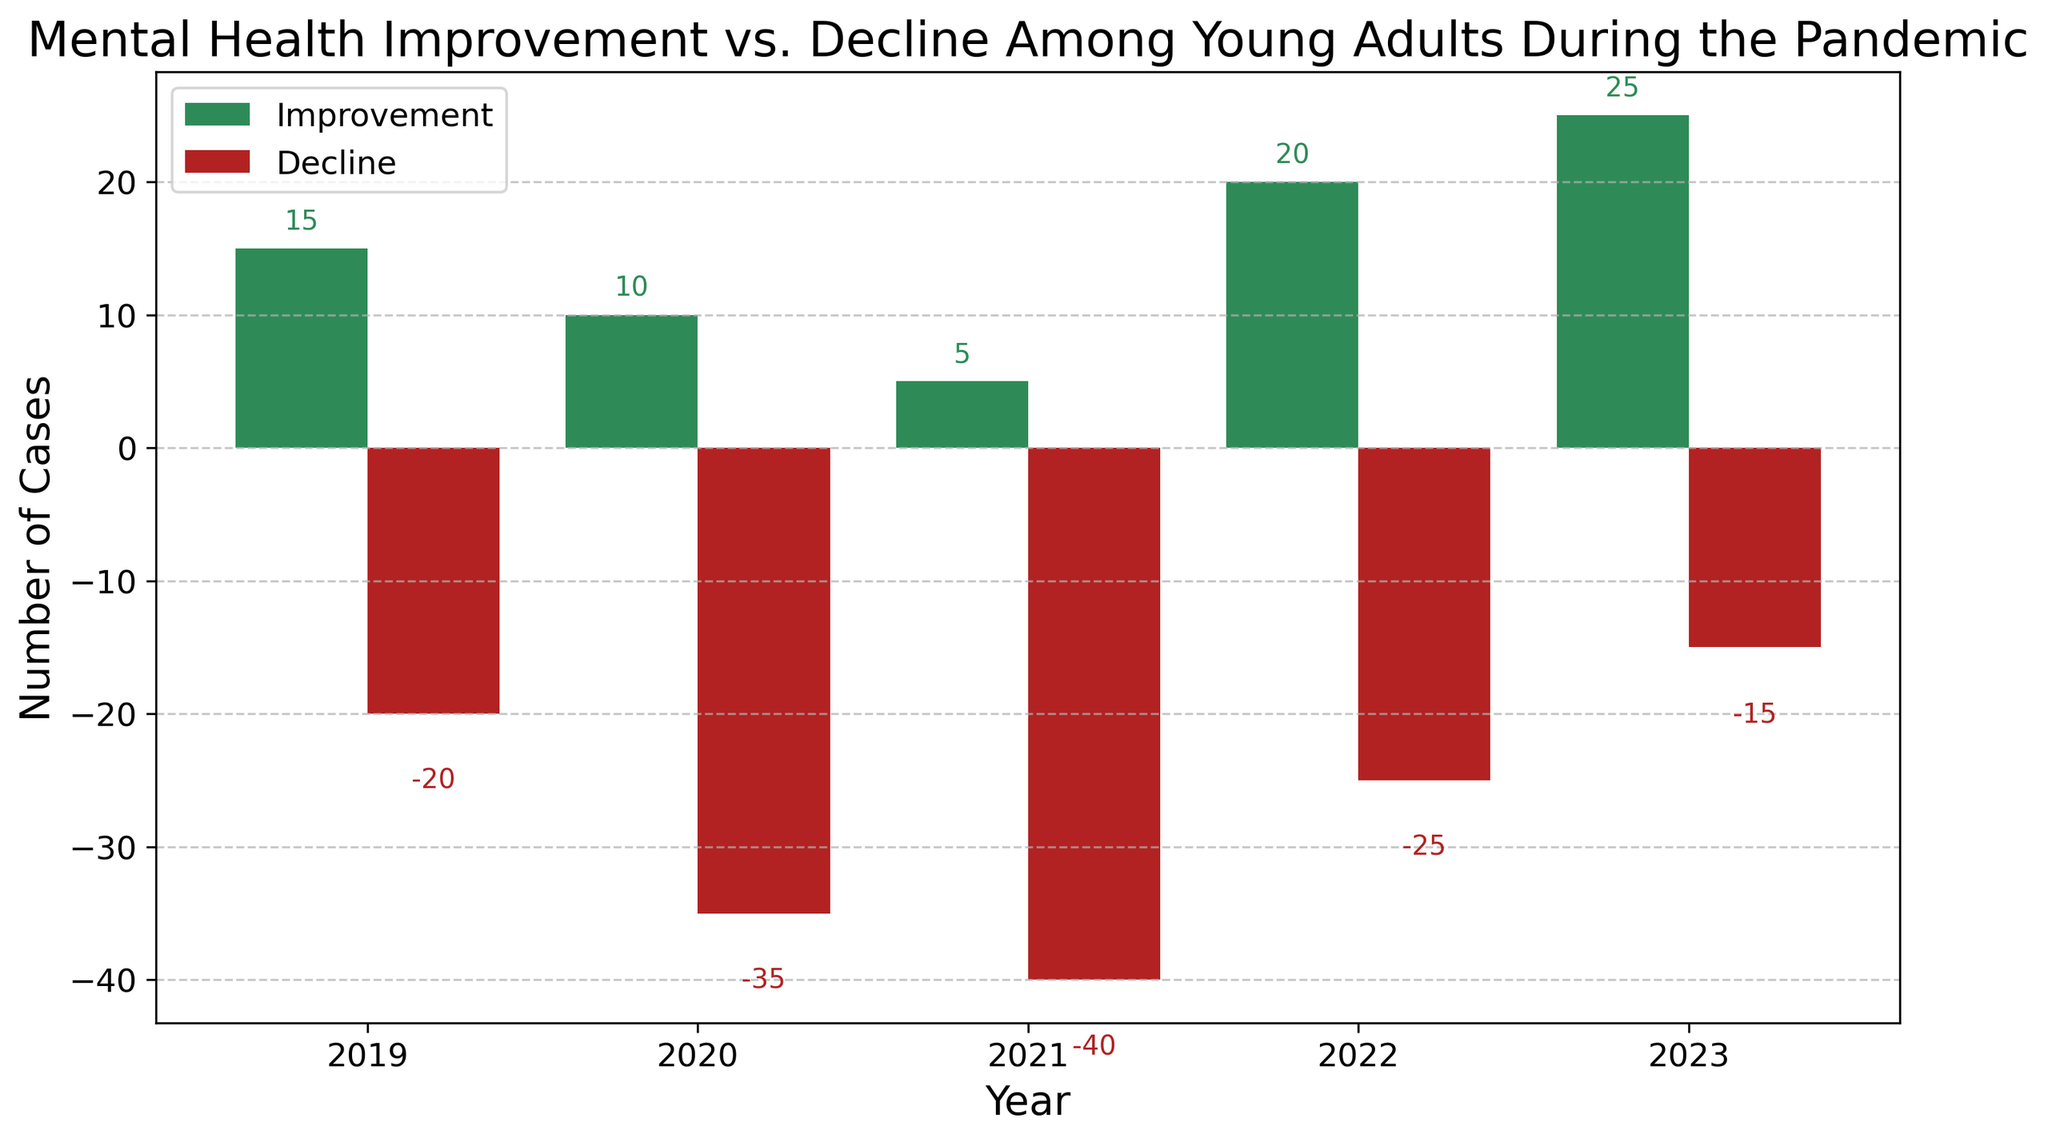What's the total number of mental health improvements from 2019-2023? To find the total number of improvements, add the values from the improvement column: 15 + 10 + 5 + 20 + 25 = 75
Answer: 75 Which year experienced the greatest decline in mental health among young adults? Compare the bar heights representing decline for each year. The year with the most significant negative value (lowest bar) represents the greatest decline. That year is 2021 with -40.
Answer: 2021 In which year was the number of improvements significantly higher than the number of declines? Look for the year where the difference between the improvement and decline values is the greatest. By examining the bars, 2023 stands out with a large visual gap where improvement (25) is much higher than decline (-15).
Answer: 2023 What's the average number of mental health improvement cases from 2020 to 2022? To find the average, sum the improvements from 2020 to 2022 and divide by the number of years: (10 + 5 + 20) / 3 = 35 / 3 = 11.67
Answer: 11.67 Comparing 2021 and 2022, how much did the improvement in mental health cases increase? Subtract the number of improvements in 2021 from those in 2022: 20 - 5 = 15
Answer: 15 How does the decline in 2019 compare to the decline in 2023? Compare their bar lengths. The decline in 2019 is -20, and in 2023 it's -15. So the decline in 2019 is 5 more than in 2023.
Answer: 5 more Was the decline in mental health cases consistent from 2019 to 2023, and if so, how? Observe the trend in the decline bars. There were fluctuations: sharply increased from 2019 to 2020 (-20 to -35), further increased to 2021 (-40), but then decreased in 2022 (-25) and 2023 (-15).
Answer: No, it was not consistent On average, do the improvements or declines show a more significant change over the years? Calculate the average change for both improvements and declines. For improvements: [(10-15) + (5-10) + (20-5) + (25-20)]/4 = [-5 -5 +15 +5]/4 = 2.5. For declines: [(35-20) + (40-35) + (25-40) + (15-25)]/4 = [15 + 5 -15 -10]/4 = -1.25. Improvements show a more significant change.
Answer: Improvements Which year has the smallest net change in mental health cases (improvement - decline = net change)? Calculate the net change for each year: 2019: 15-20=-5, 2020: 10-35=-25, 2021: 5-40=-35, 2022: 20-25=-5, 2023: 25-15=10. The smallest absolute net change is 2019 and 2022, both with -5.
Answer: 2019, 2022 